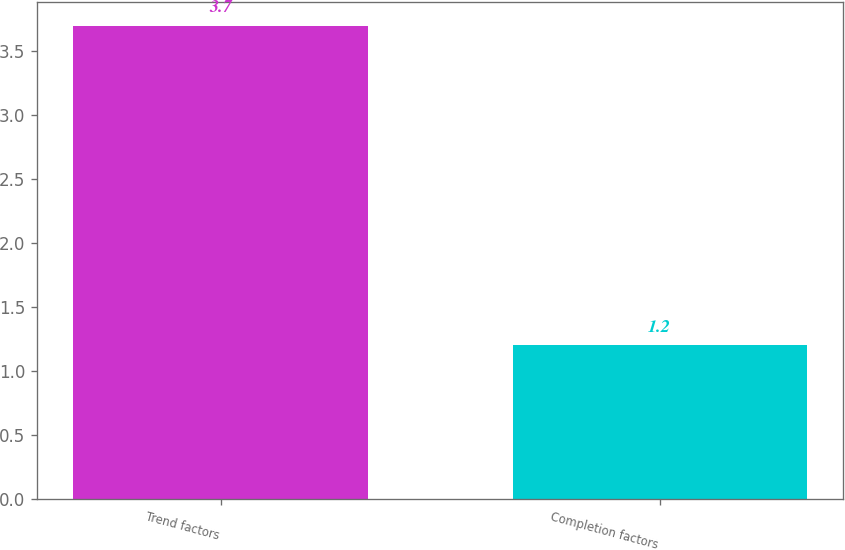Convert chart to OTSL. <chart><loc_0><loc_0><loc_500><loc_500><bar_chart><fcel>Trend factors<fcel>Completion factors<nl><fcel>3.7<fcel>1.2<nl></chart> 